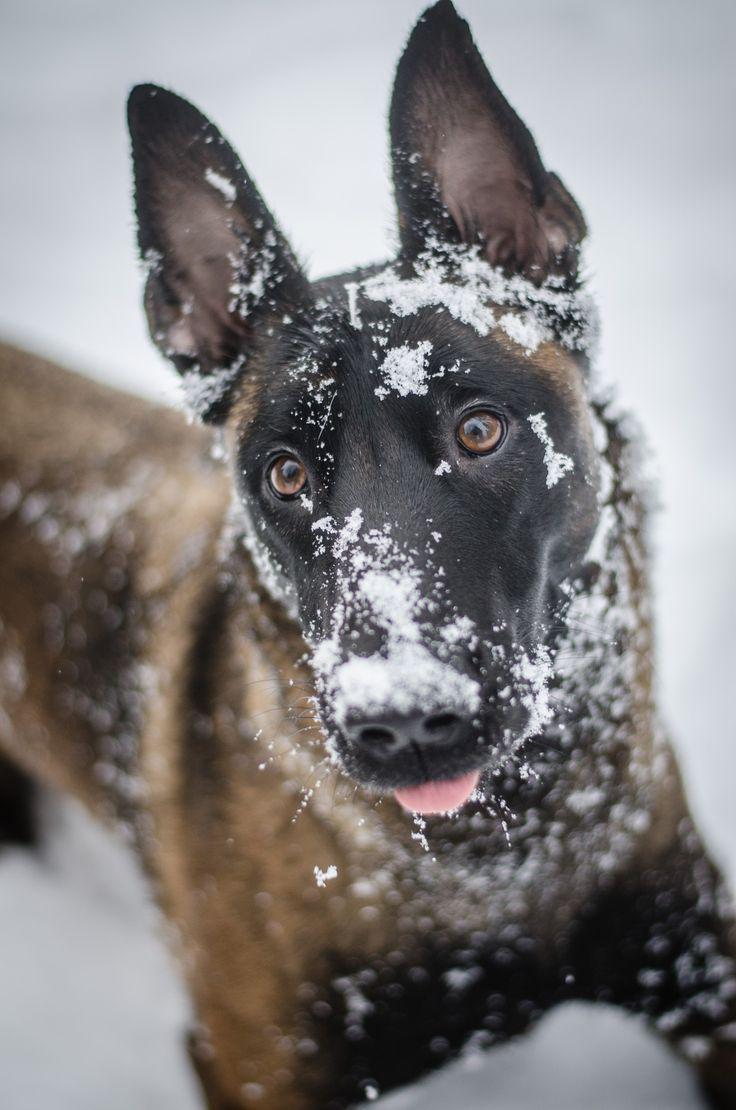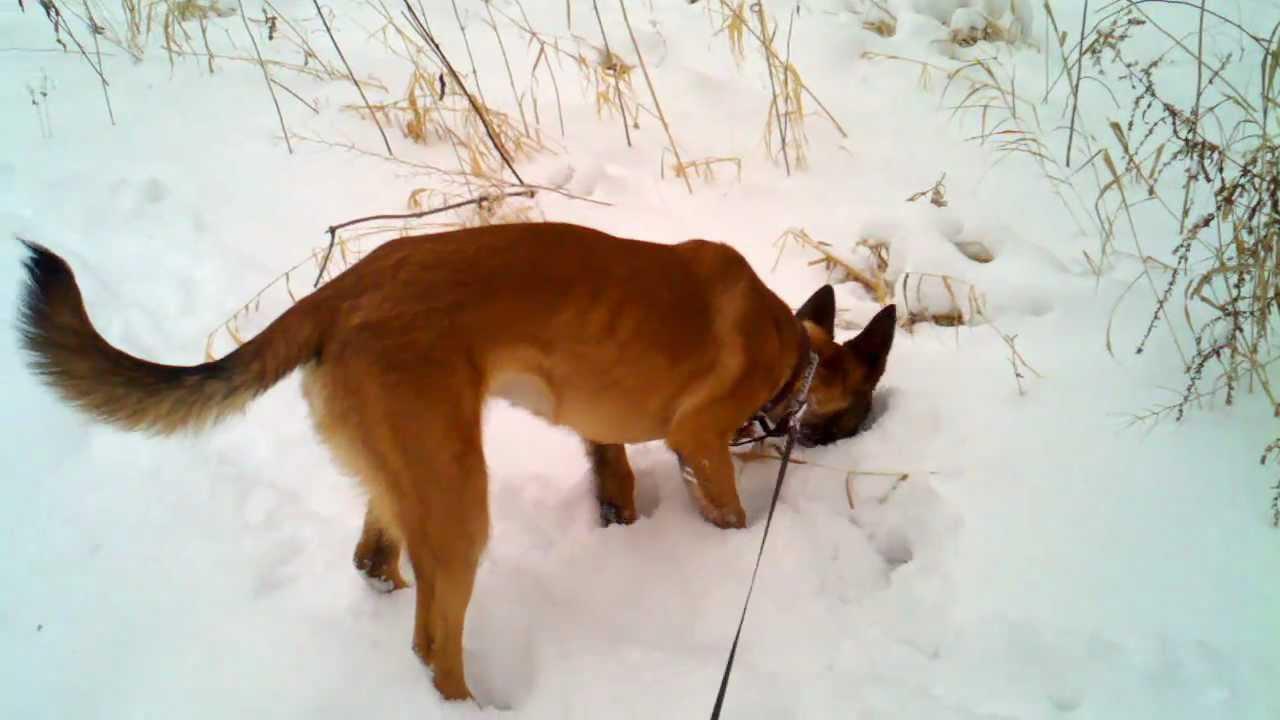The first image is the image on the left, the second image is the image on the right. Analyze the images presented: Is the assertion "Right image shows a camera-facing german shepherd dog with snow on its face." valid? Answer yes or no. No. The first image is the image on the left, the second image is the image on the right. Considering the images on both sides, is "A single dog is lying down alone in the image on the right." valid? Answer yes or no. No. 